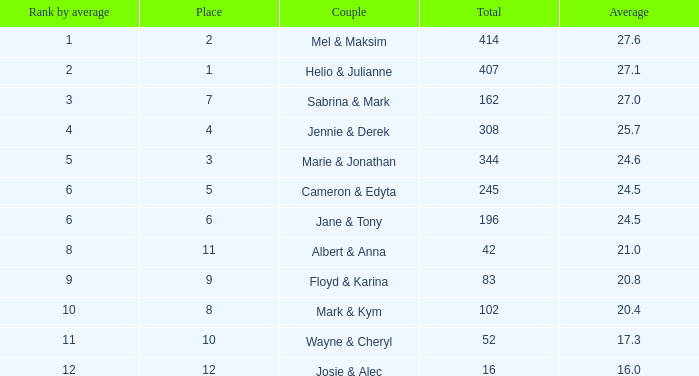Could you help me parse every detail presented in this table? {'header': ['Rank by average', 'Place', 'Couple', 'Total', 'Average'], 'rows': [['1', '2', 'Mel & Maksim', '414', '27.6'], ['2', '1', 'Helio & Julianne', '407', '27.1'], ['3', '7', 'Sabrina & Mark', '162', '27.0'], ['4', '4', 'Jennie & Derek', '308', '25.7'], ['5', '3', 'Marie & Jonathan', '344', '24.6'], ['6', '5', 'Cameron & Edyta', '245', '24.5'], ['6', '6', 'Jane & Tony', '196', '24.5'], ['8', '11', 'Albert & Anna', '42', '21.0'], ['9', '9', 'Floyd & Karina', '83', '20.8'], ['10', '8', 'Mark & Kym', '102', '20.4'], ['11', '10', 'Wayne & Cheryl', '52', '17.3'], ['12', '12', 'Josie & Alec', '16', '16.0']]} What is the rank by average where the total was larger than 245 and the average was 27.1 with fewer than 15 dances? None. 